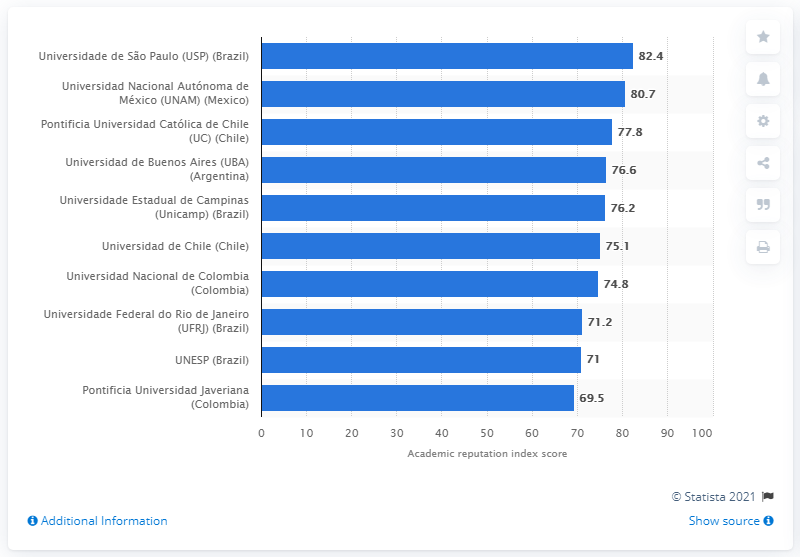Indicate a few pertinent items in this graphic. In 2020, UNAM scored 80.7. 